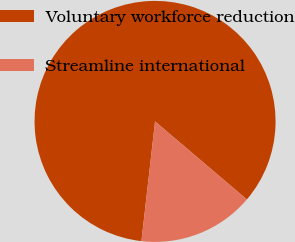Convert chart to OTSL. <chart><loc_0><loc_0><loc_500><loc_500><pie_chart><fcel>Voluntary workforce reduction<fcel>Streamline international<nl><fcel>84.41%<fcel>15.59%<nl></chart> 